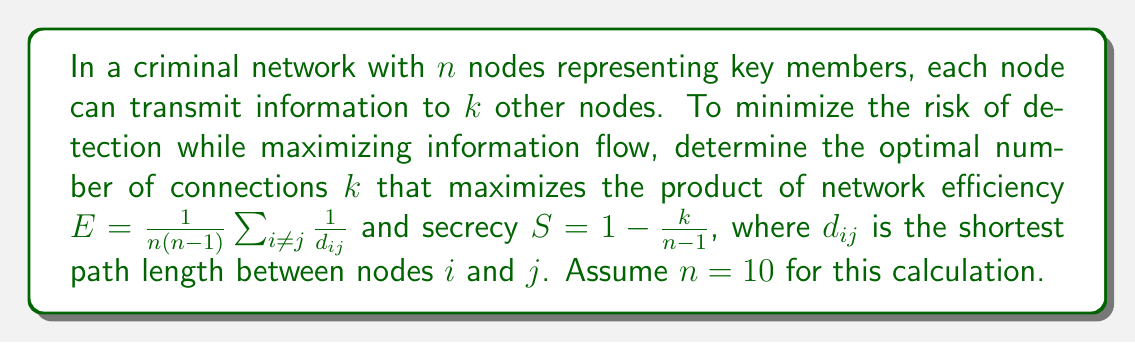Solve this math problem. 1. Define the objective function: $f(k) = E \cdot S$

2. Express $E$ in terms of $k$:
   For a network with $n$ nodes and $k$ connections per node:
   $$E \approx \frac{\log(n)}{\log(\frac{n}{k})}$$

3. Express $S$ in terms of $k$:
   $$S = 1 - \frac{k}{n-1}$$

4. Combine to get $f(k)$:
   $$f(k) = \frac{\log(n)}{\log(\frac{n}{k})} \cdot (1 - \frac{k}{n-1})$$

5. Substitute $n = 10$:
   $$f(k) = \frac{\log(10)}{\log(\frac{10}{k})} \cdot (1 - \frac{k}{9})$$

6. To find the maximum, differentiate $f(k)$ and set to zero:
   $$\frac{df}{dk} = \frac{\log(10)}{k\log^2(\frac{10}{k})} \cdot (1 - \frac{k}{9}) - \frac{\log(10)}{9\log(\frac{10}{k})} = 0$$

7. Solve numerically (e.g., using Newton's method) to find $k \approx 3.22$

8. Since $k$ must be an integer, compare $f(3)$ and $f(4)$:
   $f(3) \approx 0.3853$
   $f(4) \approx 0.3846$

9. The optimal integer value for $k$ is 3.
Answer: 3 connections per node 